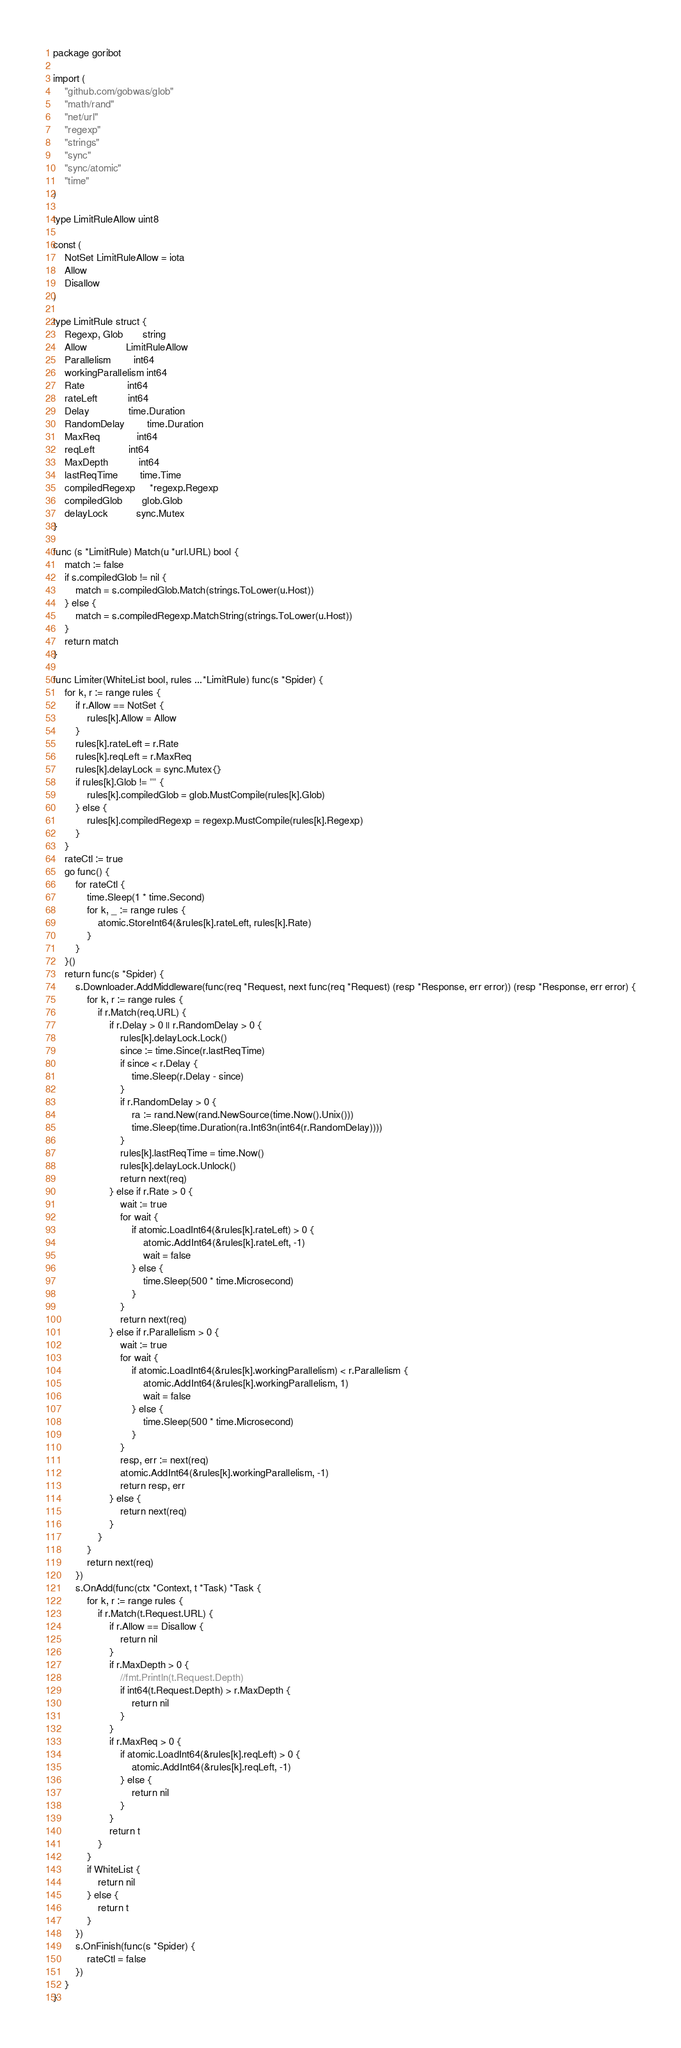Convert code to text. <code><loc_0><loc_0><loc_500><loc_500><_Go_>package goribot

import (
	"github.com/gobwas/glob"
	"math/rand"
	"net/url"
	"regexp"
	"strings"
	"sync"
	"sync/atomic"
	"time"
)

type LimitRuleAllow uint8

const (
	NotSet LimitRuleAllow = iota
	Allow
	Disallow
)

type LimitRule struct {
	Regexp, Glob       string
	Allow              LimitRuleAllow
	Parallelism        int64
	workingParallelism int64
	Rate               int64
	rateLeft           int64
	Delay              time.Duration
	RandomDelay        time.Duration
	MaxReq             int64
	reqLeft            int64
	MaxDepth           int64
	lastReqTime        time.Time
	compiledRegexp     *regexp.Regexp
	compiledGlob       glob.Glob
	delayLock          sync.Mutex
}

func (s *LimitRule) Match(u *url.URL) bool {
	match := false
	if s.compiledGlob != nil {
		match = s.compiledGlob.Match(strings.ToLower(u.Host))
	} else {
		match = s.compiledRegexp.MatchString(strings.ToLower(u.Host))
	}
	return match
}

func Limiter(WhiteList bool, rules ...*LimitRule) func(s *Spider) {
	for k, r := range rules {
		if r.Allow == NotSet {
			rules[k].Allow = Allow
		}
		rules[k].rateLeft = r.Rate
		rules[k].reqLeft = r.MaxReq
		rules[k].delayLock = sync.Mutex{}
		if rules[k].Glob != "" {
			rules[k].compiledGlob = glob.MustCompile(rules[k].Glob)
		} else {
			rules[k].compiledRegexp = regexp.MustCompile(rules[k].Regexp)
		}
	}
	rateCtl := true
	go func() {
		for rateCtl {
			time.Sleep(1 * time.Second)
			for k, _ := range rules {
				atomic.StoreInt64(&rules[k].rateLeft, rules[k].Rate)
			}
		}
	}()
	return func(s *Spider) {
		s.Downloader.AddMiddleware(func(req *Request, next func(req *Request) (resp *Response, err error)) (resp *Response, err error) {
			for k, r := range rules {
				if r.Match(req.URL) {
					if r.Delay > 0 || r.RandomDelay > 0 {
						rules[k].delayLock.Lock()
						since := time.Since(r.lastReqTime)
						if since < r.Delay {
							time.Sleep(r.Delay - since)
						}
						if r.RandomDelay > 0 {
							ra := rand.New(rand.NewSource(time.Now().Unix()))
							time.Sleep(time.Duration(ra.Int63n(int64(r.RandomDelay))))
						}
						rules[k].lastReqTime = time.Now()
						rules[k].delayLock.Unlock()
						return next(req)
					} else if r.Rate > 0 {
						wait := true
						for wait {
							if atomic.LoadInt64(&rules[k].rateLeft) > 0 {
								atomic.AddInt64(&rules[k].rateLeft, -1)
								wait = false
							} else {
								time.Sleep(500 * time.Microsecond)
							}
						}
						return next(req)
					} else if r.Parallelism > 0 {
						wait := true
						for wait {
							if atomic.LoadInt64(&rules[k].workingParallelism) < r.Parallelism {
								atomic.AddInt64(&rules[k].workingParallelism, 1)
								wait = false
							} else {
								time.Sleep(500 * time.Microsecond)
							}
						}
						resp, err := next(req)
						atomic.AddInt64(&rules[k].workingParallelism, -1)
						return resp, err
					} else {
						return next(req)
					}
				}
			}
			return next(req)
		})
		s.OnAdd(func(ctx *Context, t *Task) *Task {
			for k, r := range rules {
				if r.Match(t.Request.URL) {
					if r.Allow == Disallow {
						return nil
					}
					if r.MaxDepth > 0 {
						//fmt.Println(t.Request.Depth)
						if int64(t.Request.Depth) > r.MaxDepth {
							return nil
						}
					}
					if r.MaxReq > 0 {
						if atomic.LoadInt64(&rules[k].reqLeft) > 0 {
							atomic.AddInt64(&rules[k].reqLeft, -1)
						} else {
							return nil
						}
					}
					return t
				}
			}
			if WhiteList {
				return nil
			} else {
				return t
			}
		})
		s.OnFinish(func(s *Spider) {
			rateCtl = false
		})
	}
}
</code> 